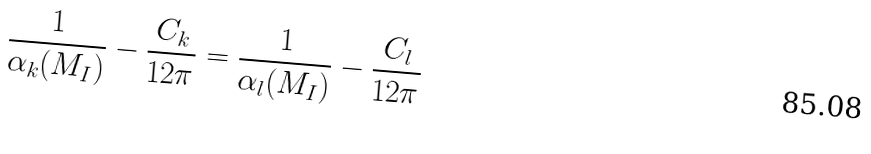Convert formula to latex. <formula><loc_0><loc_0><loc_500><loc_500>\frac { 1 } { \alpha _ { k } ( M _ { I } ) } - \frac { C _ { k } } { 1 2 \pi } = \frac { 1 } { \alpha _ { l } ( M _ { I } ) } - \frac { C _ { l } } { 1 2 \pi }</formula> 